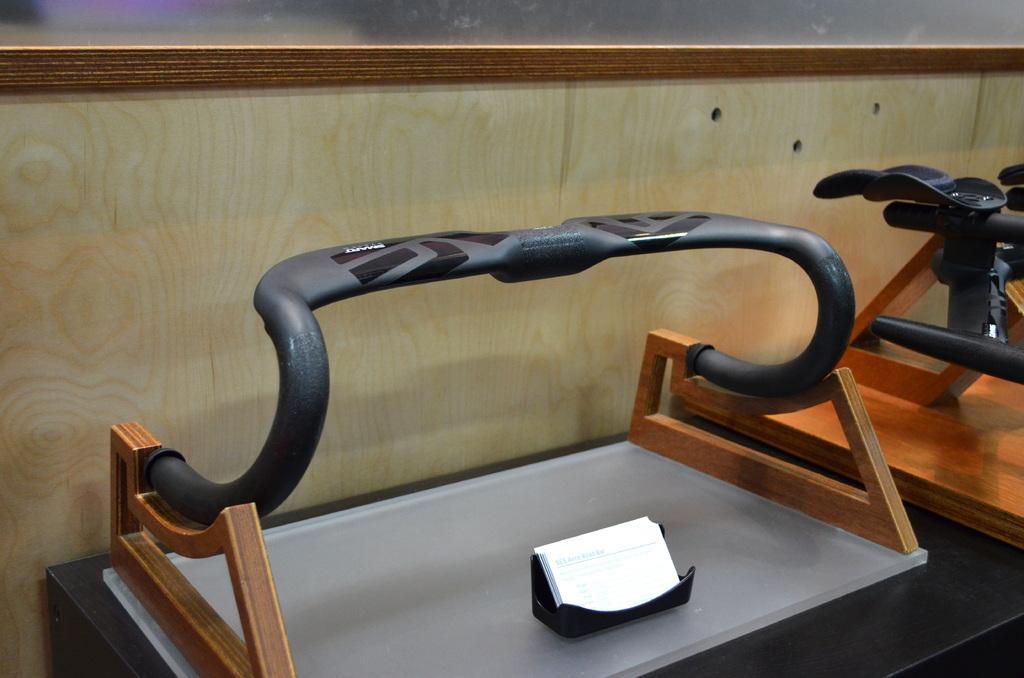Could you give a brief overview of what you see in this image? In the picture we can see a handle on the wooden stand and beside it, we can see a part of the handle to the stand. 